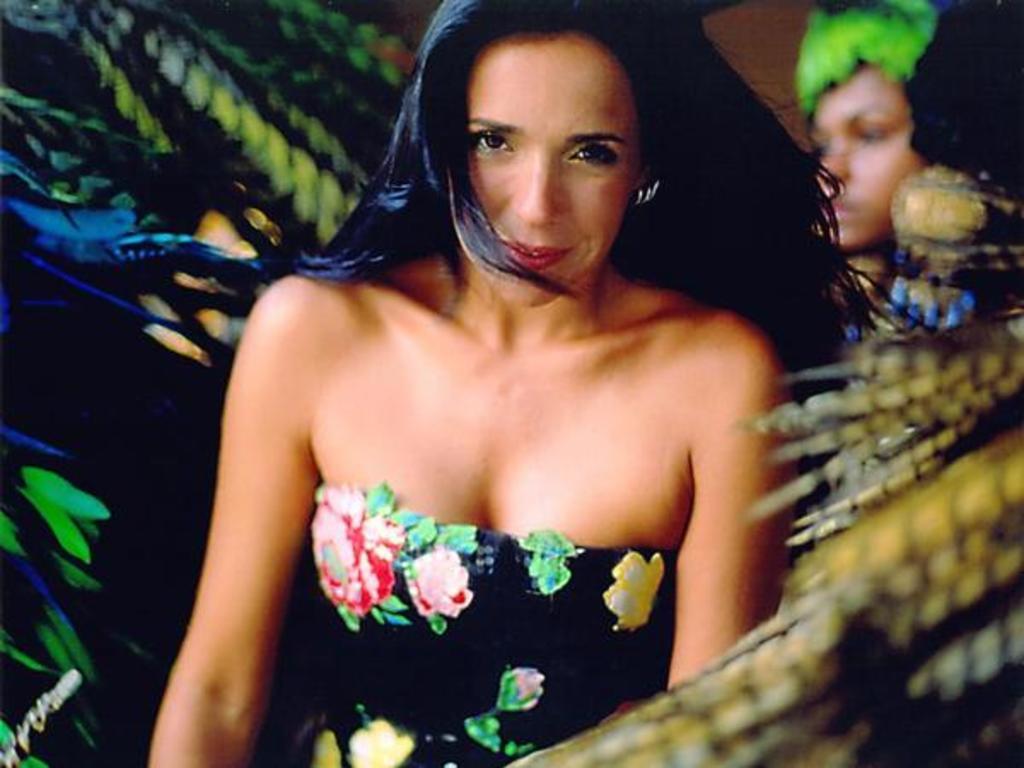In one or two sentences, can you explain what this image depicts? In the center of the image we can see a woman. We can also see the face of a woman and some feathers around her. 